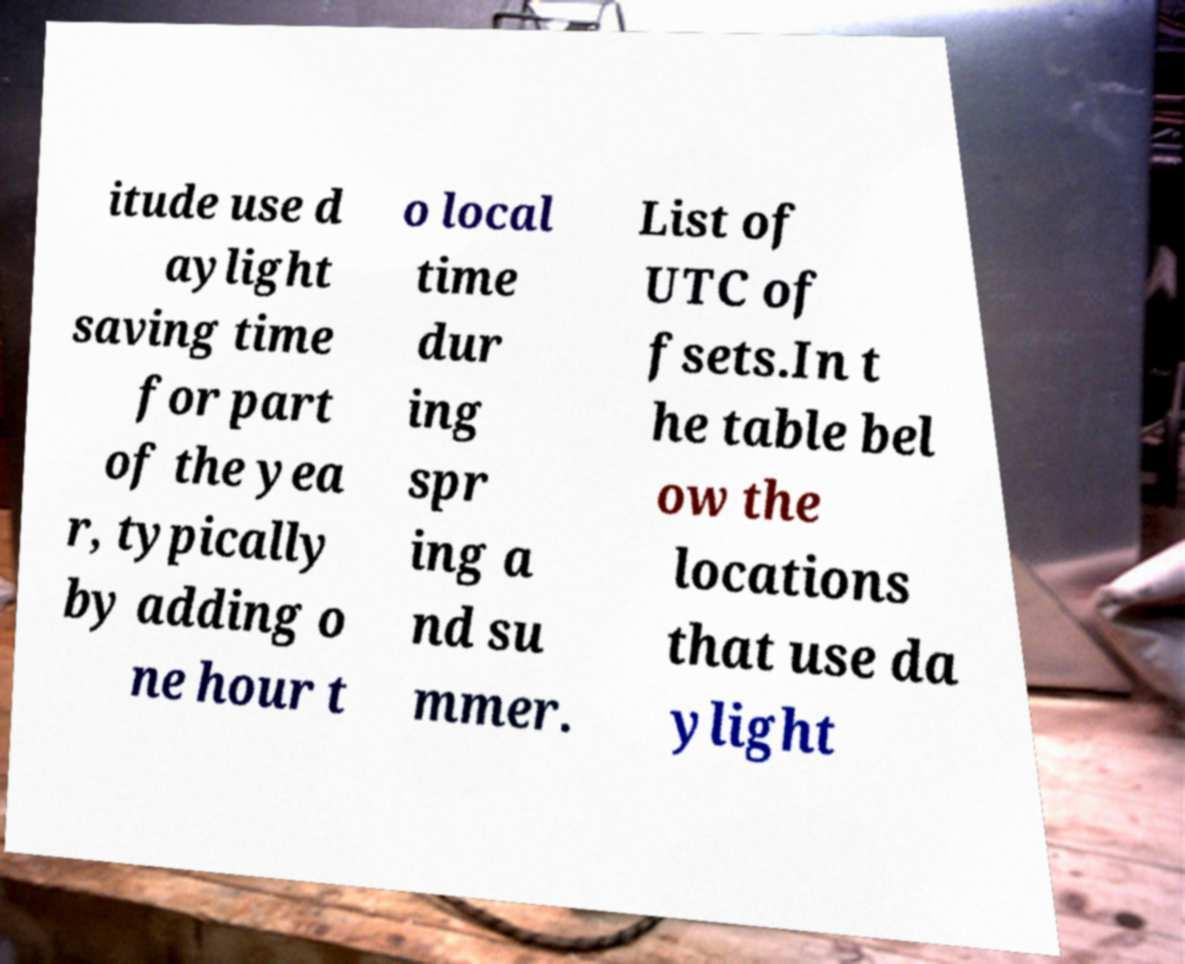There's text embedded in this image that I need extracted. Can you transcribe it verbatim? itude use d aylight saving time for part of the yea r, typically by adding o ne hour t o local time dur ing spr ing a nd su mmer. List of UTC of fsets.In t he table bel ow the locations that use da ylight 